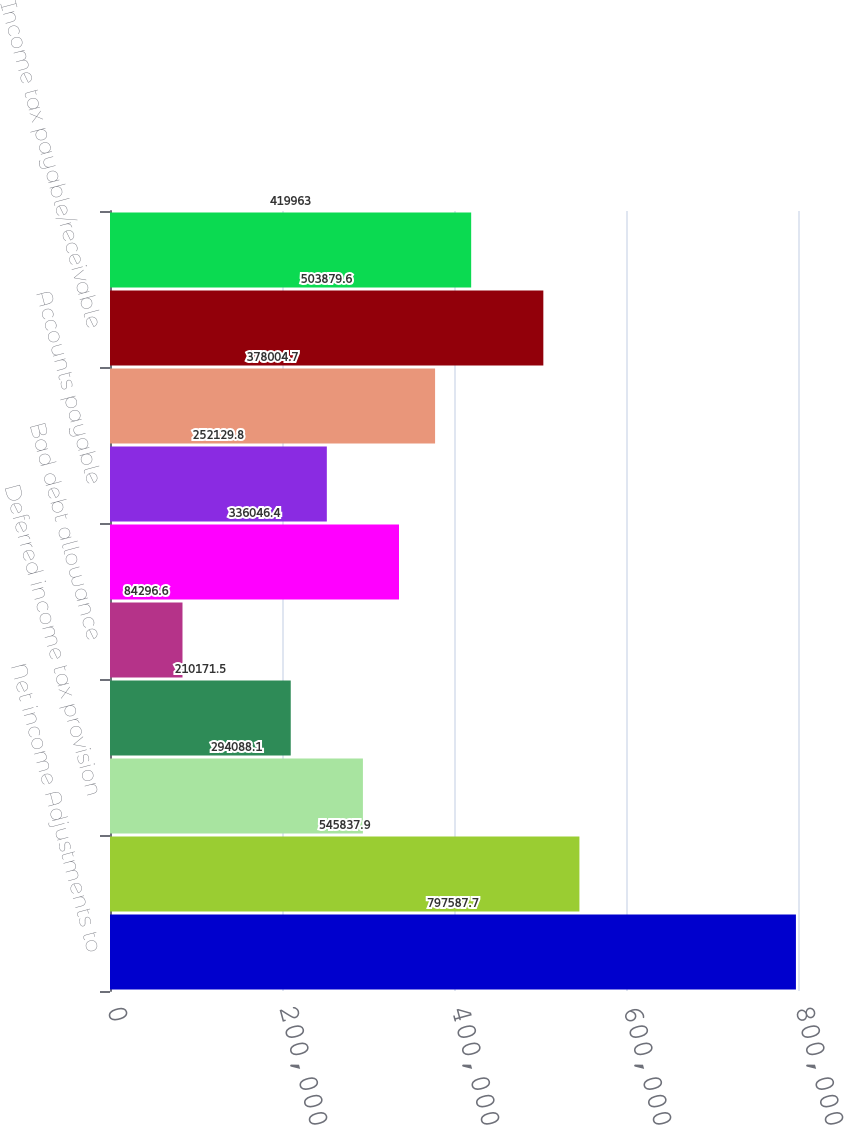<chart> <loc_0><loc_0><loc_500><loc_500><bar_chart><fcel>Net income Adjustments to<fcel>Depreciation and amortization<fcel>Deferred income tax provision<fcel>Loss on disposal of assets<fcel>Bad debt allowance<fcel>Other assets<fcel>Accounts payable<fcel>Accrued liabilities<fcel>Income tax payable/receivable<fcel>Deferred rent<nl><fcel>797588<fcel>545838<fcel>294088<fcel>210172<fcel>84296.6<fcel>336046<fcel>252130<fcel>378005<fcel>503880<fcel>419963<nl></chart> 